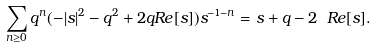Convert formula to latex. <formula><loc_0><loc_0><loc_500><loc_500>\sum _ { n \geq 0 } q ^ { n } ( - | s | ^ { 2 } - q ^ { 2 } + 2 q R e [ s ] ) s ^ { - 1 - n } = s + q - 2 \ R e [ s ] .</formula> 